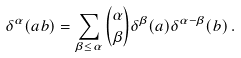Convert formula to latex. <formula><loc_0><loc_0><loc_500><loc_500>\delta ^ { \alpha } ( a b ) = \sum _ { \beta \leq \alpha } \binom { \alpha } { \beta } \delta ^ { \beta } ( a ) \delta ^ { \alpha - \beta } ( b ) \, .</formula> 